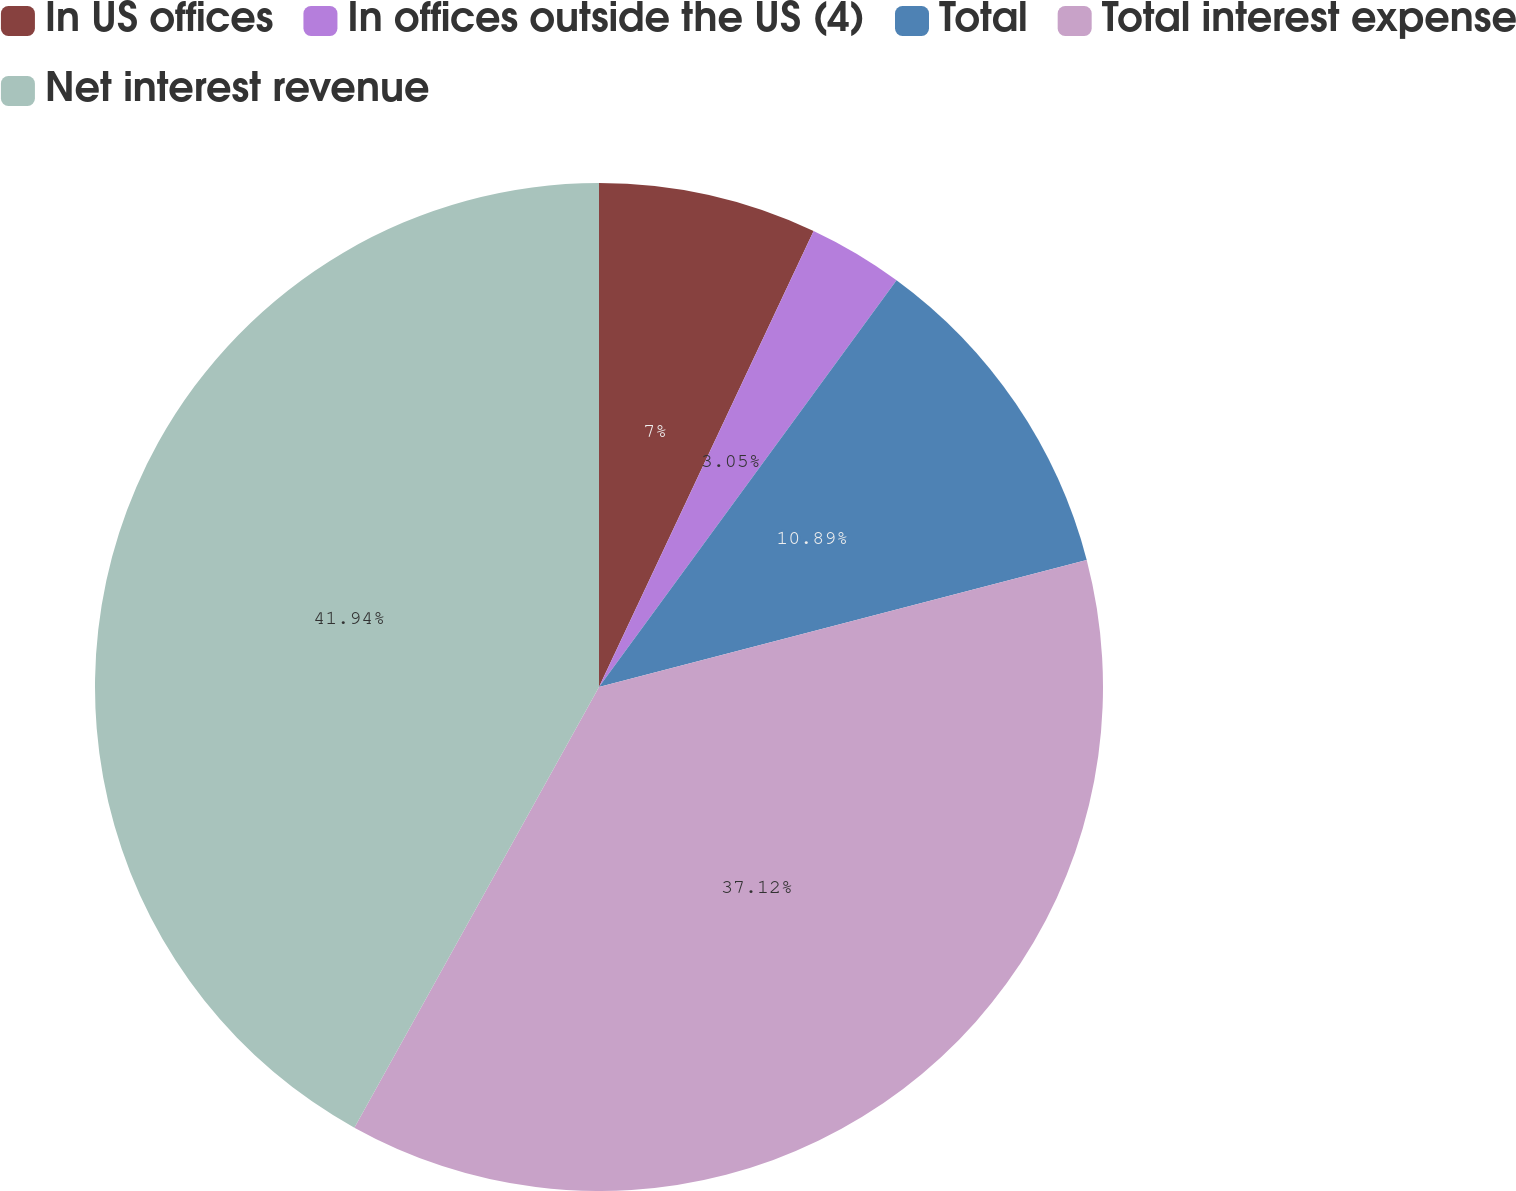<chart> <loc_0><loc_0><loc_500><loc_500><pie_chart><fcel>In US offices<fcel>In offices outside the US (4)<fcel>Total<fcel>Total interest expense<fcel>Net interest revenue<nl><fcel>7.0%<fcel>3.05%<fcel>10.89%<fcel>37.12%<fcel>41.93%<nl></chart> 